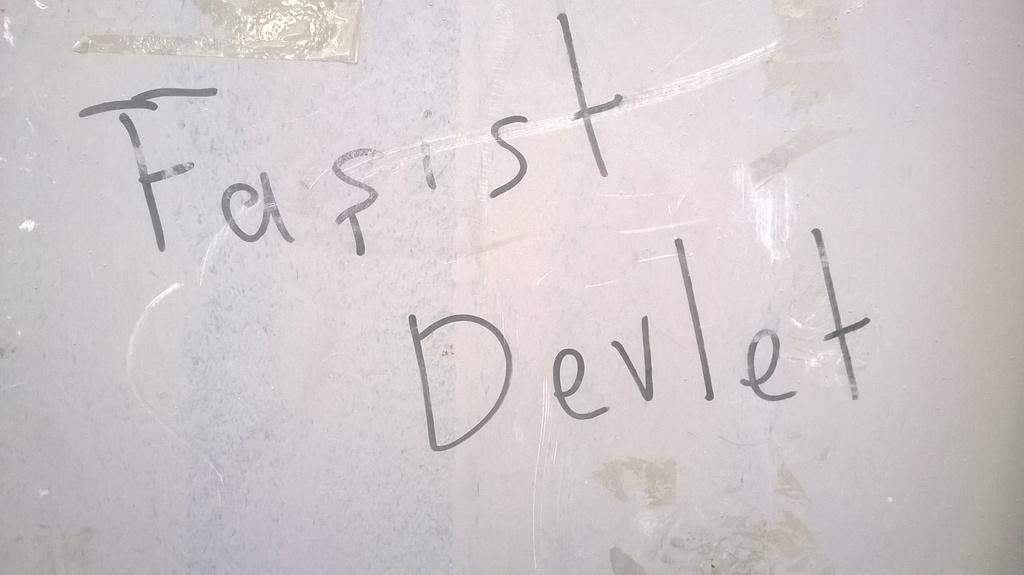Provide a one-sentence caption for the provided image. The wall has "Fasist Devlet" written on it. 